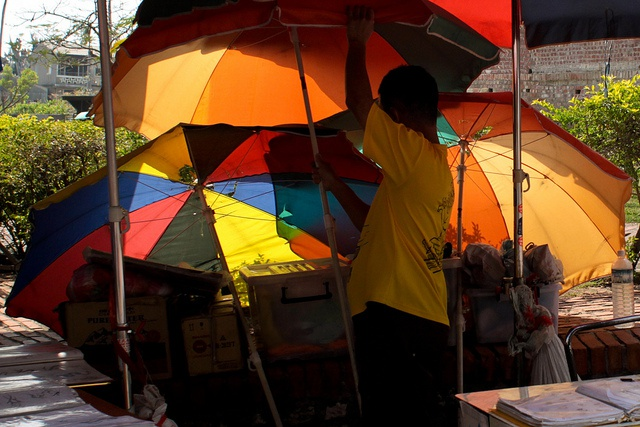Describe the objects in this image and their specific colors. I can see umbrella in white, black, maroon, gold, and darkgreen tones, umbrella in white, black, maroon, red, and orange tones, people in white, black, and maroon tones, umbrella in white, orange, brown, and red tones, and umbrella in white, black, red, maroon, and gray tones in this image. 